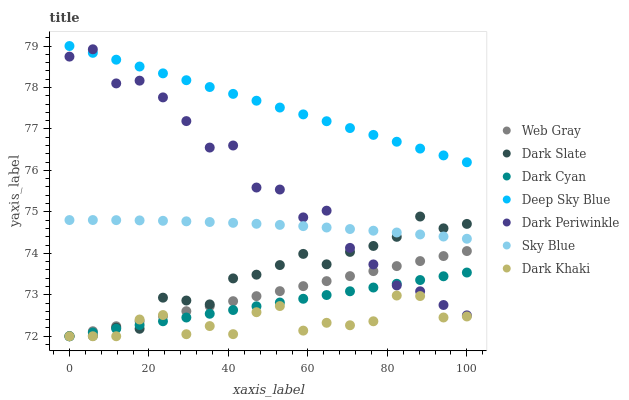Does Dark Khaki have the minimum area under the curve?
Answer yes or no. Yes. Does Deep Sky Blue have the maximum area under the curve?
Answer yes or no. Yes. Does Dark Slate have the minimum area under the curve?
Answer yes or no. No. Does Dark Slate have the maximum area under the curve?
Answer yes or no. No. Is Web Gray the smoothest?
Answer yes or no. Yes. Is Dark Periwinkle the roughest?
Answer yes or no. Yes. Is Dark Khaki the smoothest?
Answer yes or no. No. Is Dark Khaki the roughest?
Answer yes or no. No. Does Web Gray have the lowest value?
Answer yes or no. Yes. Does Deep Sky Blue have the lowest value?
Answer yes or no. No. Does Deep Sky Blue have the highest value?
Answer yes or no. Yes. Does Dark Slate have the highest value?
Answer yes or no. No. Is Sky Blue less than Deep Sky Blue?
Answer yes or no. Yes. Is Deep Sky Blue greater than Web Gray?
Answer yes or no. Yes. Does Dark Periwinkle intersect Web Gray?
Answer yes or no. Yes. Is Dark Periwinkle less than Web Gray?
Answer yes or no. No. Is Dark Periwinkle greater than Web Gray?
Answer yes or no. No. Does Sky Blue intersect Deep Sky Blue?
Answer yes or no. No. 